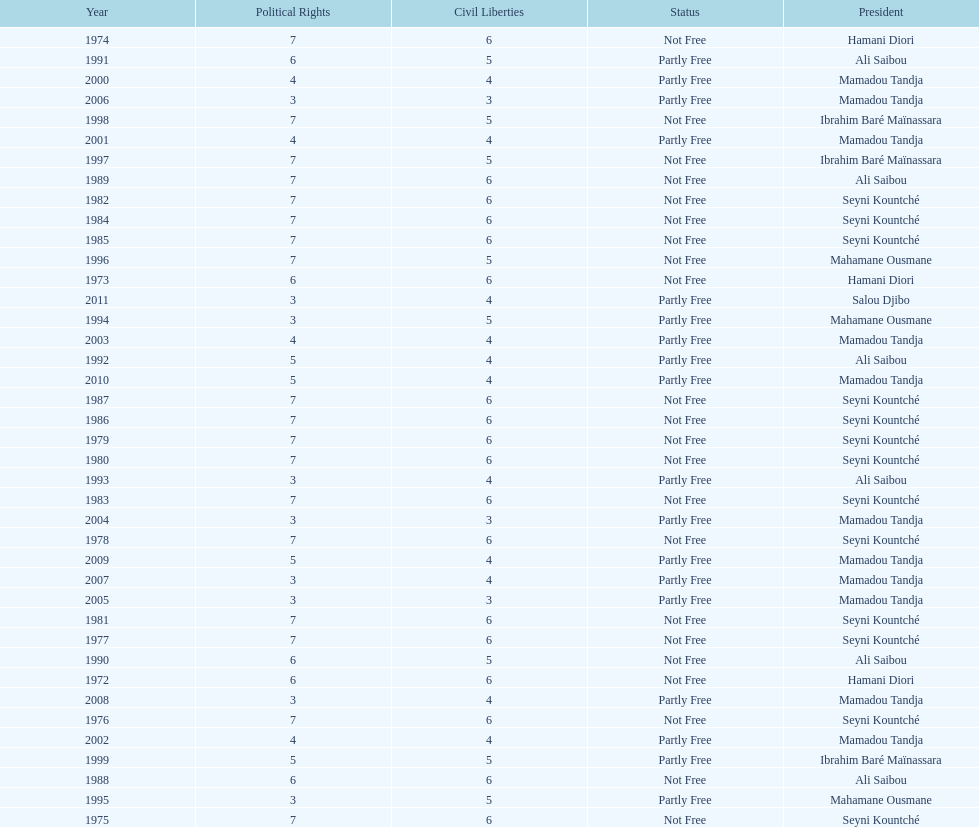Parse the full table. {'header': ['Year', 'Political Rights', 'Civil Liberties', 'Status', 'President'], 'rows': [['1974', '7', '6', 'Not Free', 'Hamani Diori'], ['1991', '6', '5', 'Partly Free', 'Ali Saibou'], ['2000', '4', '4', 'Partly Free', 'Mamadou Tandja'], ['2006', '3', '3', 'Partly Free', 'Mamadou Tandja'], ['1998', '7', '5', 'Not Free', 'Ibrahim Baré Maïnassara'], ['2001', '4', '4', 'Partly Free', 'Mamadou Tandja'], ['1997', '7', '5', 'Not Free', 'Ibrahim Baré Maïnassara'], ['1989', '7', '6', 'Not Free', 'Ali Saibou'], ['1982', '7', '6', 'Not Free', 'Seyni Kountché'], ['1984', '7', '6', 'Not Free', 'Seyni Kountché'], ['1985', '7', '6', 'Not Free', 'Seyni Kountché'], ['1996', '7', '5', 'Not Free', 'Mahamane Ousmane'], ['1973', '6', '6', 'Not Free', 'Hamani Diori'], ['2011', '3', '4', 'Partly Free', 'Salou Djibo'], ['1994', '3', '5', 'Partly Free', 'Mahamane Ousmane'], ['2003', '4', '4', 'Partly Free', 'Mamadou Tandja'], ['1992', '5', '4', 'Partly Free', 'Ali Saibou'], ['2010', '5', '4', 'Partly Free', 'Mamadou Tandja'], ['1987', '7', '6', 'Not Free', 'Seyni Kountché'], ['1986', '7', '6', 'Not Free', 'Seyni Kountché'], ['1979', '7', '6', 'Not Free', 'Seyni Kountché'], ['1980', '7', '6', 'Not Free', 'Seyni Kountché'], ['1993', '3', '4', 'Partly Free', 'Ali Saibou'], ['1983', '7', '6', 'Not Free', 'Seyni Kountché'], ['2004', '3', '3', 'Partly Free', 'Mamadou Tandja'], ['1978', '7', '6', 'Not Free', 'Seyni Kountché'], ['2009', '5', '4', 'Partly Free', 'Mamadou Tandja'], ['2007', '3', '4', 'Partly Free', 'Mamadou Tandja'], ['2005', '3', '3', 'Partly Free', 'Mamadou Tandja'], ['1981', '7', '6', 'Not Free', 'Seyni Kountché'], ['1977', '7', '6', 'Not Free', 'Seyni Kountché'], ['1990', '6', '5', 'Not Free', 'Ali Saibou'], ['1972', '6', '6', 'Not Free', 'Hamani Diori'], ['2008', '3', '4', 'Partly Free', 'Mamadou Tandja'], ['1976', '7', '6', 'Not Free', 'Seyni Kountché'], ['2002', '4', '4', 'Partly Free', 'Mamadou Tandja'], ['1999', '5', '5', 'Partly Free', 'Ibrahim Baré Maïnassara'], ['1988', '6', '6', 'Not Free', 'Ali Saibou'], ['1995', '3', '5', 'Partly Free', 'Mahamane Ousmane'], ['1975', '7', '6', 'Not Free', 'Seyni Kountché']]} What is the number of time seyni kountche has been president? 13. 